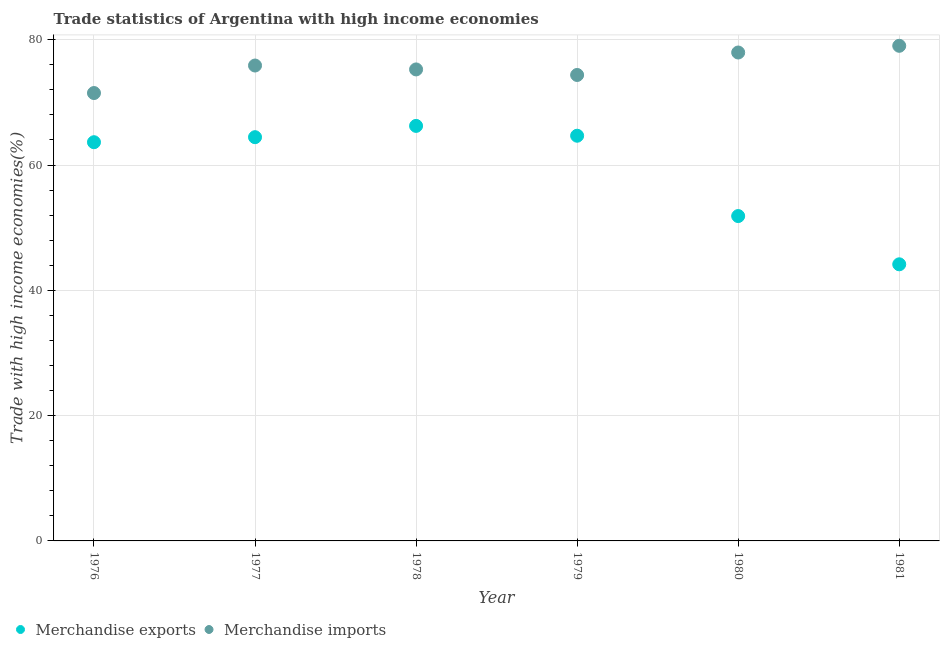How many different coloured dotlines are there?
Your response must be concise. 2. Is the number of dotlines equal to the number of legend labels?
Keep it short and to the point. Yes. What is the merchandise imports in 1979?
Give a very brief answer. 74.37. Across all years, what is the maximum merchandise imports?
Keep it short and to the point. 79.03. Across all years, what is the minimum merchandise imports?
Provide a succinct answer. 71.49. In which year was the merchandise exports maximum?
Your answer should be compact. 1978. What is the total merchandise exports in the graph?
Ensure brevity in your answer.  355. What is the difference between the merchandise exports in 1979 and that in 1981?
Provide a short and direct response. 20.52. What is the difference between the merchandise imports in 1978 and the merchandise exports in 1977?
Offer a terse response. 10.82. What is the average merchandise exports per year?
Ensure brevity in your answer.  59.17. In the year 1981, what is the difference between the merchandise exports and merchandise imports?
Your answer should be very brief. -34.88. What is the ratio of the merchandise imports in 1978 to that in 1981?
Give a very brief answer. 0.95. Is the merchandise exports in 1977 less than that in 1978?
Offer a very short reply. Yes. What is the difference between the highest and the second highest merchandise exports?
Give a very brief answer. 1.57. What is the difference between the highest and the lowest merchandise exports?
Provide a short and direct response. 22.09. Is the sum of the merchandise exports in 1979 and 1980 greater than the maximum merchandise imports across all years?
Your answer should be very brief. Yes. Is the merchandise imports strictly greater than the merchandise exports over the years?
Provide a succinct answer. Yes. How many dotlines are there?
Provide a short and direct response. 2. What is the difference between two consecutive major ticks on the Y-axis?
Provide a succinct answer. 20. Are the values on the major ticks of Y-axis written in scientific E-notation?
Provide a succinct answer. No. How many legend labels are there?
Ensure brevity in your answer.  2. How are the legend labels stacked?
Your response must be concise. Horizontal. What is the title of the graph?
Your answer should be compact. Trade statistics of Argentina with high income economies. Does "Quasi money growth" appear as one of the legend labels in the graph?
Provide a succinct answer. No. What is the label or title of the X-axis?
Offer a terse response. Year. What is the label or title of the Y-axis?
Give a very brief answer. Trade with high income economies(%). What is the Trade with high income economies(%) of Merchandise exports in 1976?
Offer a terse response. 63.64. What is the Trade with high income economies(%) in Merchandise imports in 1976?
Provide a succinct answer. 71.49. What is the Trade with high income economies(%) of Merchandise exports in 1977?
Your response must be concise. 64.44. What is the Trade with high income economies(%) of Merchandise imports in 1977?
Ensure brevity in your answer.  75.88. What is the Trade with high income economies(%) in Merchandise exports in 1978?
Provide a short and direct response. 66.24. What is the Trade with high income economies(%) in Merchandise imports in 1978?
Provide a short and direct response. 75.26. What is the Trade with high income economies(%) in Merchandise exports in 1979?
Offer a very short reply. 64.67. What is the Trade with high income economies(%) of Merchandise imports in 1979?
Offer a very short reply. 74.37. What is the Trade with high income economies(%) of Merchandise exports in 1980?
Ensure brevity in your answer.  51.85. What is the Trade with high income economies(%) in Merchandise imports in 1980?
Offer a very short reply. 77.96. What is the Trade with high income economies(%) in Merchandise exports in 1981?
Keep it short and to the point. 44.15. What is the Trade with high income economies(%) in Merchandise imports in 1981?
Your answer should be very brief. 79.03. Across all years, what is the maximum Trade with high income economies(%) in Merchandise exports?
Provide a succinct answer. 66.24. Across all years, what is the maximum Trade with high income economies(%) in Merchandise imports?
Make the answer very short. 79.03. Across all years, what is the minimum Trade with high income economies(%) of Merchandise exports?
Offer a very short reply. 44.15. Across all years, what is the minimum Trade with high income economies(%) of Merchandise imports?
Give a very brief answer. 71.49. What is the total Trade with high income economies(%) in Merchandise exports in the graph?
Keep it short and to the point. 355. What is the total Trade with high income economies(%) of Merchandise imports in the graph?
Your response must be concise. 453.99. What is the difference between the Trade with high income economies(%) in Merchandise exports in 1976 and that in 1977?
Offer a terse response. -0.8. What is the difference between the Trade with high income economies(%) of Merchandise imports in 1976 and that in 1977?
Offer a terse response. -4.39. What is the difference between the Trade with high income economies(%) in Merchandise exports in 1976 and that in 1978?
Your answer should be very brief. -2.6. What is the difference between the Trade with high income economies(%) of Merchandise imports in 1976 and that in 1978?
Provide a short and direct response. -3.77. What is the difference between the Trade with high income economies(%) of Merchandise exports in 1976 and that in 1979?
Provide a succinct answer. -1.03. What is the difference between the Trade with high income economies(%) in Merchandise imports in 1976 and that in 1979?
Your answer should be very brief. -2.88. What is the difference between the Trade with high income economies(%) in Merchandise exports in 1976 and that in 1980?
Your answer should be compact. 11.79. What is the difference between the Trade with high income economies(%) in Merchandise imports in 1976 and that in 1980?
Make the answer very short. -6.47. What is the difference between the Trade with high income economies(%) of Merchandise exports in 1976 and that in 1981?
Offer a terse response. 19.49. What is the difference between the Trade with high income economies(%) of Merchandise imports in 1976 and that in 1981?
Provide a short and direct response. -7.54. What is the difference between the Trade with high income economies(%) of Merchandise exports in 1977 and that in 1978?
Your response must be concise. -1.8. What is the difference between the Trade with high income economies(%) in Merchandise imports in 1977 and that in 1978?
Make the answer very short. 0.62. What is the difference between the Trade with high income economies(%) in Merchandise exports in 1977 and that in 1979?
Your response must be concise. -0.23. What is the difference between the Trade with high income economies(%) of Merchandise imports in 1977 and that in 1979?
Offer a terse response. 1.51. What is the difference between the Trade with high income economies(%) of Merchandise exports in 1977 and that in 1980?
Offer a terse response. 12.59. What is the difference between the Trade with high income economies(%) of Merchandise imports in 1977 and that in 1980?
Make the answer very short. -2.08. What is the difference between the Trade with high income economies(%) in Merchandise exports in 1977 and that in 1981?
Make the answer very short. 20.29. What is the difference between the Trade with high income economies(%) in Merchandise imports in 1977 and that in 1981?
Your answer should be very brief. -3.15. What is the difference between the Trade with high income economies(%) of Merchandise exports in 1978 and that in 1979?
Your answer should be very brief. 1.57. What is the difference between the Trade with high income economies(%) in Merchandise imports in 1978 and that in 1979?
Give a very brief answer. 0.89. What is the difference between the Trade with high income economies(%) in Merchandise exports in 1978 and that in 1980?
Make the answer very short. 14.39. What is the difference between the Trade with high income economies(%) in Merchandise imports in 1978 and that in 1980?
Provide a short and direct response. -2.7. What is the difference between the Trade with high income economies(%) in Merchandise exports in 1978 and that in 1981?
Offer a very short reply. 22.09. What is the difference between the Trade with high income economies(%) of Merchandise imports in 1978 and that in 1981?
Ensure brevity in your answer.  -3.77. What is the difference between the Trade with high income economies(%) in Merchandise exports in 1979 and that in 1980?
Ensure brevity in your answer.  12.82. What is the difference between the Trade with high income economies(%) in Merchandise imports in 1979 and that in 1980?
Provide a succinct answer. -3.59. What is the difference between the Trade with high income economies(%) in Merchandise exports in 1979 and that in 1981?
Keep it short and to the point. 20.52. What is the difference between the Trade with high income economies(%) in Merchandise imports in 1979 and that in 1981?
Your answer should be very brief. -4.66. What is the difference between the Trade with high income economies(%) in Merchandise exports in 1980 and that in 1981?
Provide a succinct answer. 7.7. What is the difference between the Trade with high income economies(%) of Merchandise imports in 1980 and that in 1981?
Your response must be concise. -1.07. What is the difference between the Trade with high income economies(%) in Merchandise exports in 1976 and the Trade with high income economies(%) in Merchandise imports in 1977?
Your response must be concise. -12.24. What is the difference between the Trade with high income economies(%) in Merchandise exports in 1976 and the Trade with high income economies(%) in Merchandise imports in 1978?
Ensure brevity in your answer.  -11.62. What is the difference between the Trade with high income economies(%) of Merchandise exports in 1976 and the Trade with high income economies(%) of Merchandise imports in 1979?
Make the answer very short. -10.73. What is the difference between the Trade with high income economies(%) of Merchandise exports in 1976 and the Trade with high income economies(%) of Merchandise imports in 1980?
Provide a short and direct response. -14.32. What is the difference between the Trade with high income economies(%) of Merchandise exports in 1976 and the Trade with high income economies(%) of Merchandise imports in 1981?
Give a very brief answer. -15.39. What is the difference between the Trade with high income economies(%) in Merchandise exports in 1977 and the Trade with high income economies(%) in Merchandise imports in 1978?
Provide a succinct answer. -10.82. What is the difference between the Trade with high income economies(%) of Merchandise exports in 1977 and the Trade with high income economies(%) of Merchandise imports in 1979?
Ensure brevity in your answer.  -9.93. What is the difference between the Trade with high income economies(%) of Merchandise exports in 1977 and the Trade with high income economies(%) of Merchandise imports in 1980?
Provide a succinct answer. -13.52. What is the difference between the Trade with high income economies(%) of Merchandise exports in 1977 and the Trade with high income economies(%) of Merchandise imports in 1981?
Make the answer very short. -14.59. What is the difference between the Trade with high income economies(%) in Merchandise exports in 1978 and the Trade with high income economies(%) in Merchandise imports in 1979?
Your answer should be very brief. -8.13. What is the difference between the Trade with high income economies(%) of Merchandise exports in 1978 and the Trade with high income economies(%) of Merchandise imports in 1980?
Provide a succinct answer. -11.72. What is the difference between the Trade with high income economies(%) in Merchandise exports in 1978 and the Trade with high income economies(%) in Merchandise imports in 1981?
Give a very brief answer. -12.79. What is the difference between the Trade with high income economies(%) in Merchandise exports in 1979 and the Trade with high income economies(%) in Merchandise imports in 1980?
Ensure brevity in your answer.  -13.28. What is the difference between the Trade with high income economies(%) of Merchandise exports in 1979 and the Trade with high income economies(%) of Merchandise imports in 1981?
Make the answer very short. -14.35. What is the difference between the Trade with high income economies(%) in Merchandise exports in 1980 and the Trade with high income economies(%) in Merchandise imports in 1981?
Provide a short and direct response. -27.18. What is the average Trade with high income economies(%) of Merchandise exports per year?
Give a very brief answer. 59.17. What is the average Trade with high income economies(%) of Merchandise imports per year?
Provide a succinct answer. 75.66. In the year 1976, what is the difference between the Trade with high income economies(%) of Merchandise exports and Trade with high income economies(%) of Merchandise imports?
Keep it short and to the point. -7.85. In the year 1977, what is the difference between the Trade with high income economies(%) in Merchandise exports and Trade with high income economies(%) in Merchandise imports?
Your answer should be very brief. -11.44. In the year 1978, what is the difference between the Trade with high income economies(%) of Merchandise exports and Trade with high income economies(%) of Merchandise imports?
Offer a very short reply. -9.01. In the year 1979, what is the difference between the Trade with high income economies(%) of Merchandise exports and Trade with high income economies(%) of Merchandise imports?
Your answer should be compact. -9.7. In the year 1980, what is the difference between the Trade with high income economies(%) in Merchandise exports and Trade with high income economies(%) in Merchandise imports?
Your response must be concise. -26.11. In the year 1981, what is the difference between the Trade with high income economies(%) of Merchandise exports and Trade with high income economies(%) of Merchandise imports?
Your answer should be very brief. -34.88. What is the ratio of the Trade with high income economies(%) in Merchandise exports in 1976 to that in 1977?
Make the answer very short. 0.99. What is the ratio of the Trade with high income economies(%) of Merchandise imports in 1976 to that in 1977?
Offer a terse response. 0.94. What is the ratio of the Trade with high income economies(%) in Merchandise exports in 1976 to that in 1978?
Provide a succinct answer. 0.96. What is the ratio of the Trade with high income economies(%) in Merchandise imports in 1976 to that in 1978?
Offer a terse response. 0.95. What is the ratio of the Trade with high income economies(%) of Merchandise imports in 1976 to that in 1979?
Your response must be concise. 0.96. What is the ratio of the Trade with high income economies(%) in Merchandise exports in 1976 to that in 1980?
Ensure brevity in your answer.  1.23. What is the ratio of the Trade with high income economies(%) in Merchandise imports in 1976 to that in 1980?
Provide a succinct answer. 0.92. What is the ratio of the Trade with high income economies(%) of Merchandise exports in 1976 to that in 1981?
Provide a short and direct response. 1.44. What is the ratio of the Trade with high income economies(%) in Merchandise imports in 1976 to that in 1981?
Your answer should be very brief. 0.9. What is the ratio of the Trade with high income economies(%) of Merchandise exports in 1977 to that in 1978?
Offer a very short reply. 0.97. What is the ratio of the Trade with high income economies(%) in Merchandise imports in 1977 to that in 1978?
Your response must be concise. 1.01. What is the ratio of the Trade with high income economies(%) of Merchandise exports in 1977 to that in 1979?
Your response must be concise. 1. What is the ratio of the Trade with high income economies(%) in Merchandise imports in 1977 to that in 1979?
Offer a very short reply. 1.02. What is the ratio of the Trade with high income economies(%) in Merchandise exports in 1977 to that in 1980?
Offer a very short reply. 1.24. What is the ratio of the Trade with high income economies(%) in Merchandise imports in 1977 to that in 1980?
Provide a short and direct response. 0.97. What is the ratio of the Trade with high income economies(%) of Merchandise exports in 1977 to that in 1981?
Give a very brief answer. 1.46. What is the ratio of the Trade with high income economies(%) in Merchandise imports in 1977 to that in 1981?
Give a very brief answer. 0.96. What is the ratio of the Trade with high income economies(%) of Merchandise exports in 1978 to that in 1979?
Your answer should be compact. 1.02. What is the ratio of the Trade with high income economies(%) of Merchandise imports in 1978 to that in 1979?
Provide a short and direct response. 1.01. What is the ratio of the Trade with high income economies(%) of Merchandise exports in 1978 to that in 1980?
Ensure brevity in your answer.  1.28. What is the ratio of the Trade with high income economies(%) of Merchandise imports in 1978 to that in 1980?
Your answer should be compact. 0.97. What is the ratio of the Trade with high income economies(%) of Merchandise exports in 1978 to that in 1981?
Your answer should be very brief. 1.5. What is the ratio of the Trade with high income economies(%) of Merchandise imports in 1978 to that in 1981?
Your response must be concise. 0.95. What is the ratio of the Trade with high income economies(%) of Merchandise exports in 1979 to that in 1980?
Provide a short and direct response. 1.25. What is the ratio of the Trade with high income economies(%) in Merchandise imports in 1979 to that in 1980?
Provide a succinct answer. 0.95. What is the ratio of the Trade with high income economies(%) in Merchandise exports in 1979 to that in 1981?
Provide a short and direct response. 1.46. What is the ratio of the Trade with high income economies(%) in Merchandise imports in 1979 to that in 1981?
Provide a short and direct response. 0.94. What is the ratio of the Trade with high income economies(%) in Merchandise exports in 1980 to that in 1981?
Keep it short and to the point. 1.17. What is the ratio of the Trade with high income economies(%) of Merchandise imports in 1980 to that in 1981?
Your answer should be compact. 0.99. What is the difference between the highest and the second highest Trade with high income economies(%) of Merchandise exports?
Offer a terse response. 1.57. What is the difference between the highest and the second highest Trade with high income economies(%) in Merchandise imports?
Your answer should be compact. 1.07. What is the difference between the highest and the lowest Trade with high income economies(%) of Merchandise exports?
Make the answer very short. 22.09. What is the difference between the highest and the lowest Trade with high income economies(%) of Merchandise imports?
Ensure brevity in your answer.  7.54. 